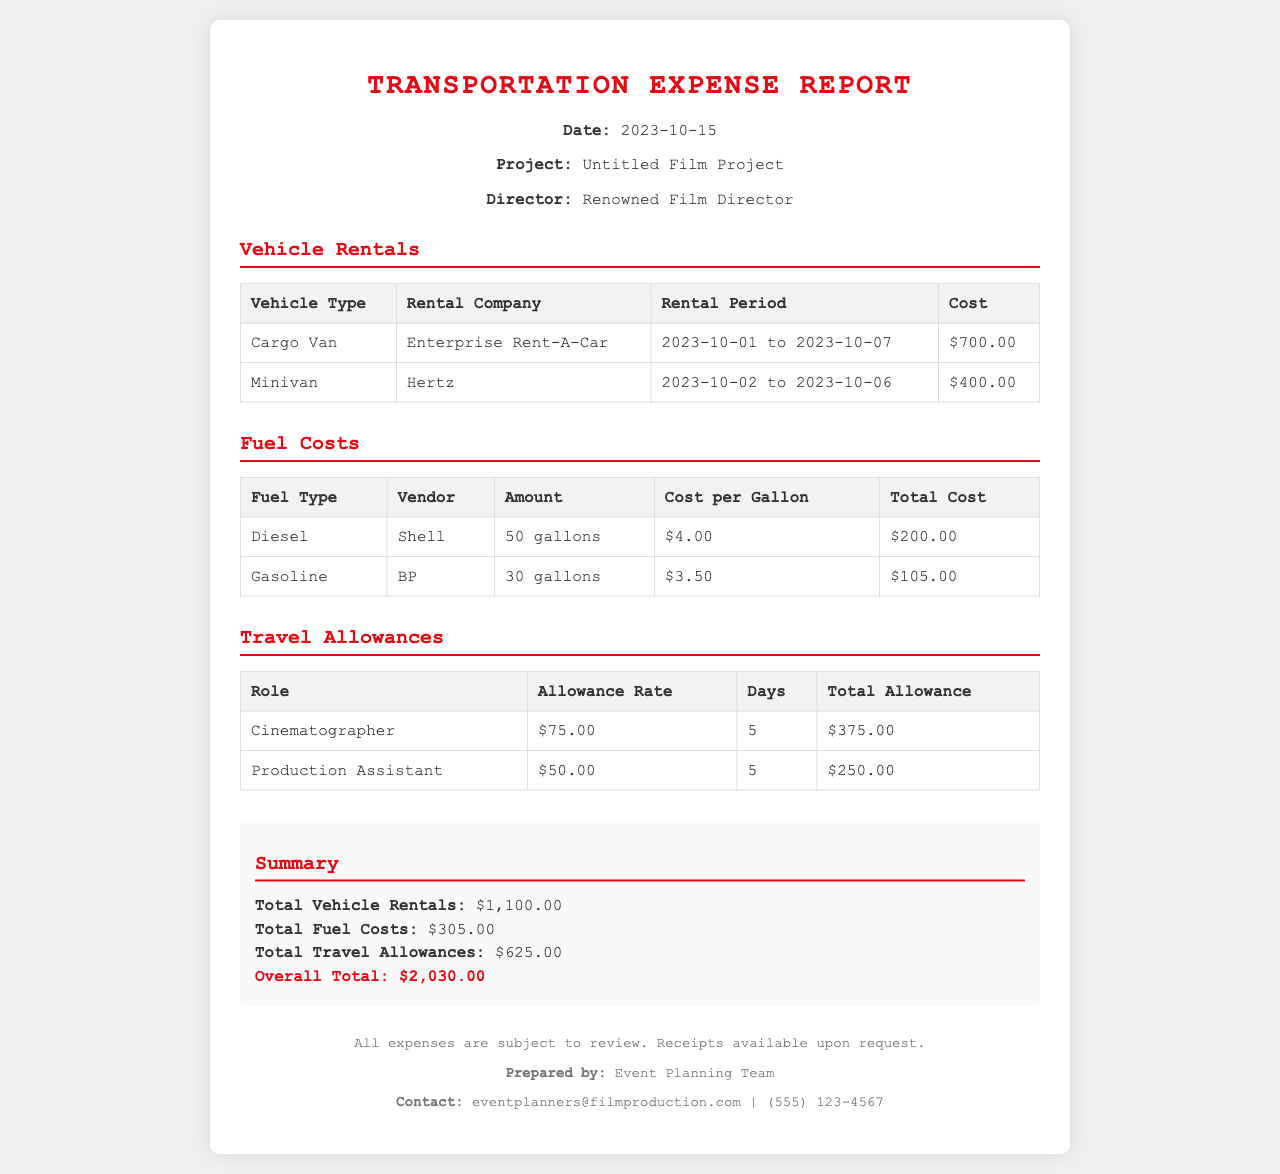What is the date of the report? The date is mentioned in the header info of the report.
Answer: 2023-10-15 Who is the director of the project? The director's name is stated in the header info section.
Answer: Renowned Film Director How much did the rental company charge for the minivan? The cost for the minivan is listed in the vehicle rentals section.
Answer: $400.00 What is the total cost of diesel fuel? The total cost for diesel fuel is provided in the fuel costs table.
Answer: $200.00 How many gallons of gasoline were purchased? The amount of gasoline purchased is given in the fuel costs section.
Answer: 30 gallons What is the overall total for all expenses? The overall total is the sum of vehicle rentals, fuel costs, and travel allowances in the summary section.
Answer: $2,030.00 What is the allowance rate for the production assistant? The allowance rate for the production assistant is mentioned in the travel allowances table.
Answer: $50.00 How many days of allowance were calculated for the cinematographer? The number of days for the cinematographer is specified in the travel allowances section.
Answer: 5 Who prepared the transportation expense report? The name of the team that prepared the report is mentioned in the footer.
Answer: Event Planning Team 